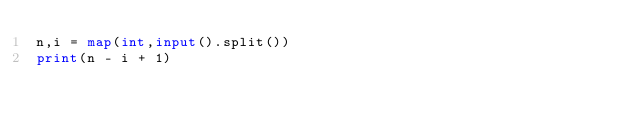<code> <loc_0><loc_0><loc_500><loc_500><_Python_>n,i = map(int,input().split())
print(n - i + 1)</code> 